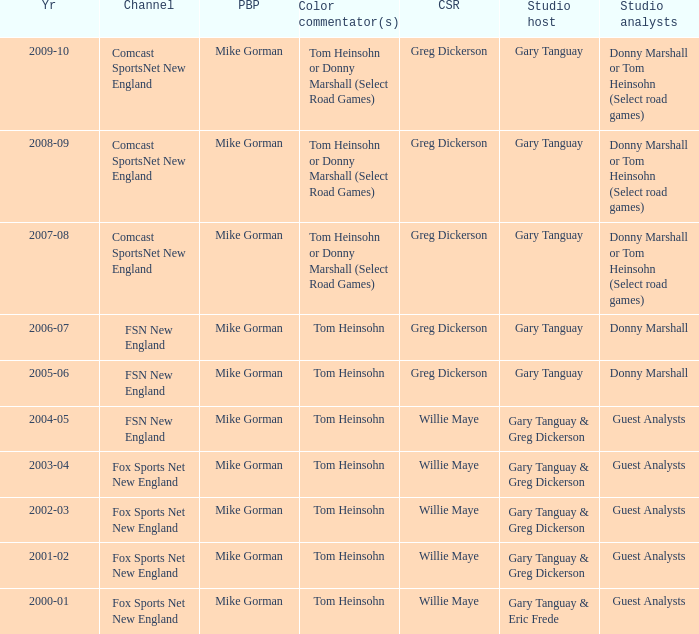Which Color commentator has a Channel of fsn new england, and a Year of 2004-05? Tom Heinsohn. 